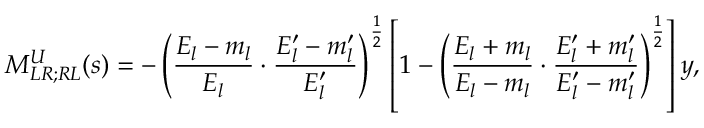<formula> <loc_0><loc_0><loc_500><loc_500>M _ { L R ; R L } ^ { U } ( s ) = - \left ( \frac { E _ { l } - m _ { l } } { E _ { l } } \cdot \frac { E _ { l } ^ { \prime } - m _ { l } ^ { \prime } } { E _ { l } ^ { \prime } } \right ) ^ { \frac { 1 } { 2 } } \left [ 1 - \left ( \frac { E _ { l } + m _ { l } } { E _ { l } - m _ { l } } \cdot \frac { E _ { l } ^ { \prime } + m _ { l } ^ { \prime } } { E _ { l } ^ { \prime } - m _ { l } ^ { \prime } } \right ) ^ { \frac { 1 } { 2 } } \right ] y ,</formula> 